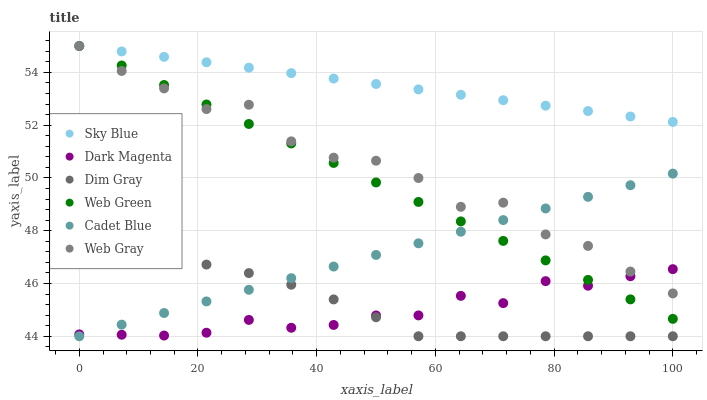Does Dark Magenta have the minimum area under the curve?
Answer yes or no. Yes. Does Sky Blue have the maximum area under the curve?
Answer yes or no. Yes. Does Web Green have the minimum area under the curve?
Answer yes or no. No. Does Web Green have the maximum area under the curve?
Answer yes or no. No. Is Cadet Blue the smoothest?
Answer yes or no. Yes. Is Web Gray the roughest?
Answer yes or no. Yes. Is Dark Magenta the smoothest?
Answer yes or no. No. Is Dark Magenta the roughest?
Answer yes or no. No. Does Cadet Blue have the lowest value?
Answer yes or no. Yes. Does Dark Magenta have the lowest value?
Answer yes or no. No. Does Sky Blue have the highest value?
Answer yes or no. Yes. Does Dark Magenta have the highest value?
Answer yes or no. No. Is Dim Gray less than Sky Blue?
Answer yes or no. Yes. Is Sky Blue greater than Dark Magenta?
Answer yes or no. Yes. Does Dark Magenta intersect Web Green?
Answer yes or no. Yes. Is Dark Magenta less than Web Green?
Answer yes or no. No. Is Dark Magenta greater than Web Green?
Answer yes or no. No. Does Dim Gray intersect Sky Blue?
Answer yes or no. No. 